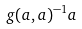Convert formula to latex. <formula><loc_0><loc_0><loc_500><loc_500>g ( a , a ) ^ { - 1 } a</formula> 